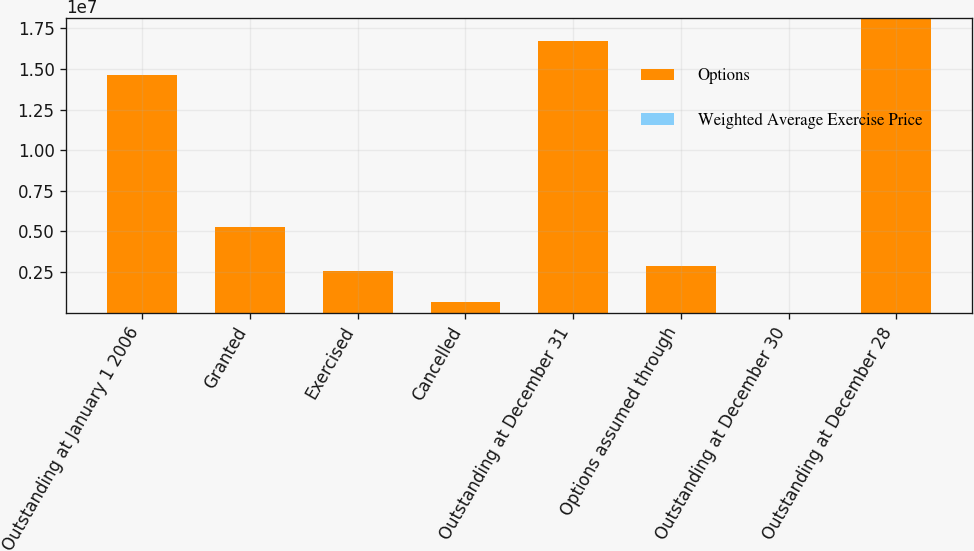Convert chart. <chart><loc_0><loc_0><loc_500><loc_500><stacked_bar_chart><ecel><fcel>Outstanding at January 1 2006<fcel>Granted<fcel>Exercised<fcel>Cancelled<fcel>Outstanding at December 31<fcel>Options assumed through<fcel>Outstanding at December 30<fcel>Outstanding at December 28<nl><fcel>Options<fcel>1.46509e+07<fcel>5.2421e+06<fcel>2.54624e+06<fcel>628484<fcel>1.67182e+07<fcel>2.84866e+06<fcel>16.26<fcel>1.81342e+07<nl><fcel>Weighted Average Exercise Price<fcel>3.98<fcel>13.62<fcel>3.64<fcel>6.22<fcel>6.97<fcel>10.69<fcel>12.13<fcel>16.26<nl></chart> 